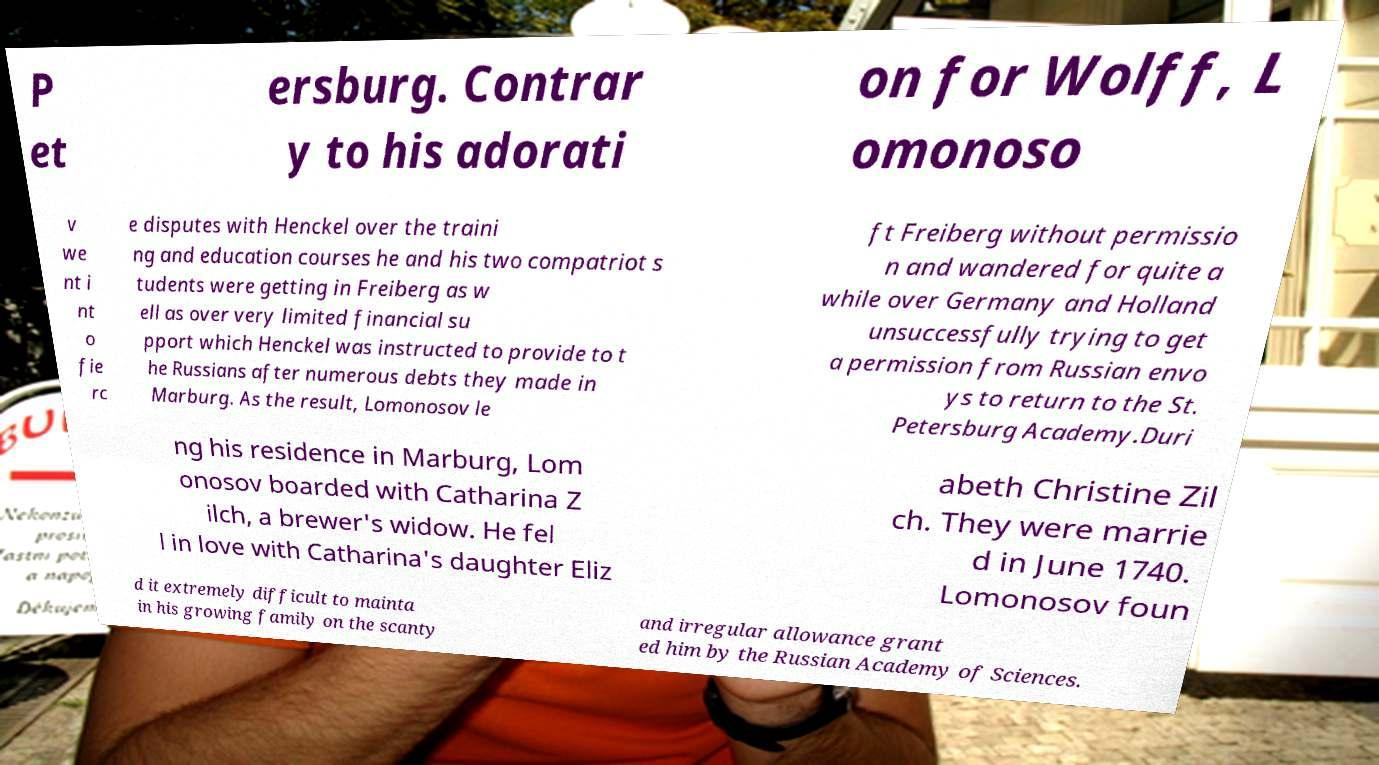I need the written content from this picture converted into text. Can you do that? P et ersburg. Contrar y to his adorati on for Wolff, L omonoso v we nt i nt o fie rc e disputes with Henckel over the traini ng and education courses he and his two compatriot s tudents were getting in Freiberg as w ell as over very limited financial su pport which Henckel was instructed to provide to t he Russians after numerous debts they made in Marburg. As the result, Lomonosov le ft Freiberg without permissio n and wandered for quite a while over Germany and Holland unsuccessfully trying to get a permission from Russian envo ys to return to the St. Petersburg Academy.Duri ng his residence in Marburg, Lom onosov boarded with Catharina Z ilch, a brewer's widow. He fel l in love with Catharina's daughter Eliz abeth Christine Zil ch. They were marrie d in June 1740. Lomonosov foun d it extremely difficult to mainta in his growing family on the scanty and irregular allowance grant ed him by the Russian Academy of Sciences. 